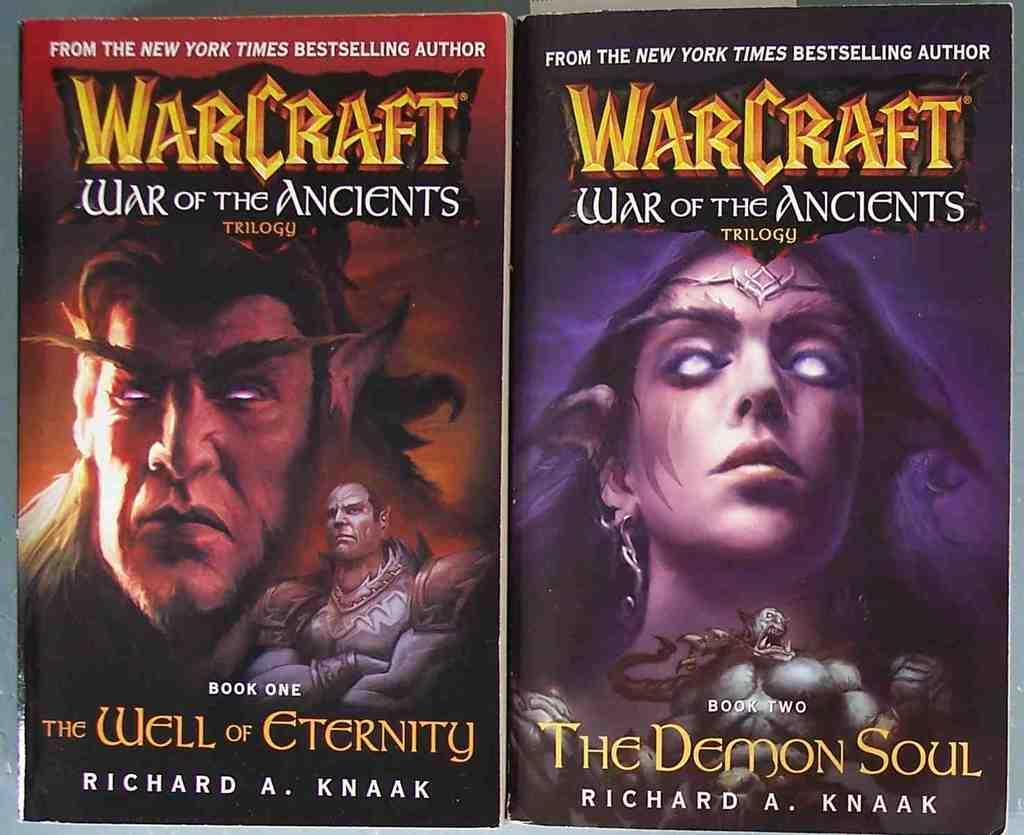What is located in the center of the image? There are two posters in the center of the image. What can be seen on each poster? Each poster has a person depicted on it. What else is featured on the posters besides the images? There is text present on the posters. What type of verse can be seen written on the leg of the person depicted on the poster? There is no verse written on the leg of the person depicted on the poster; the image only shows a person and text on the posters. 